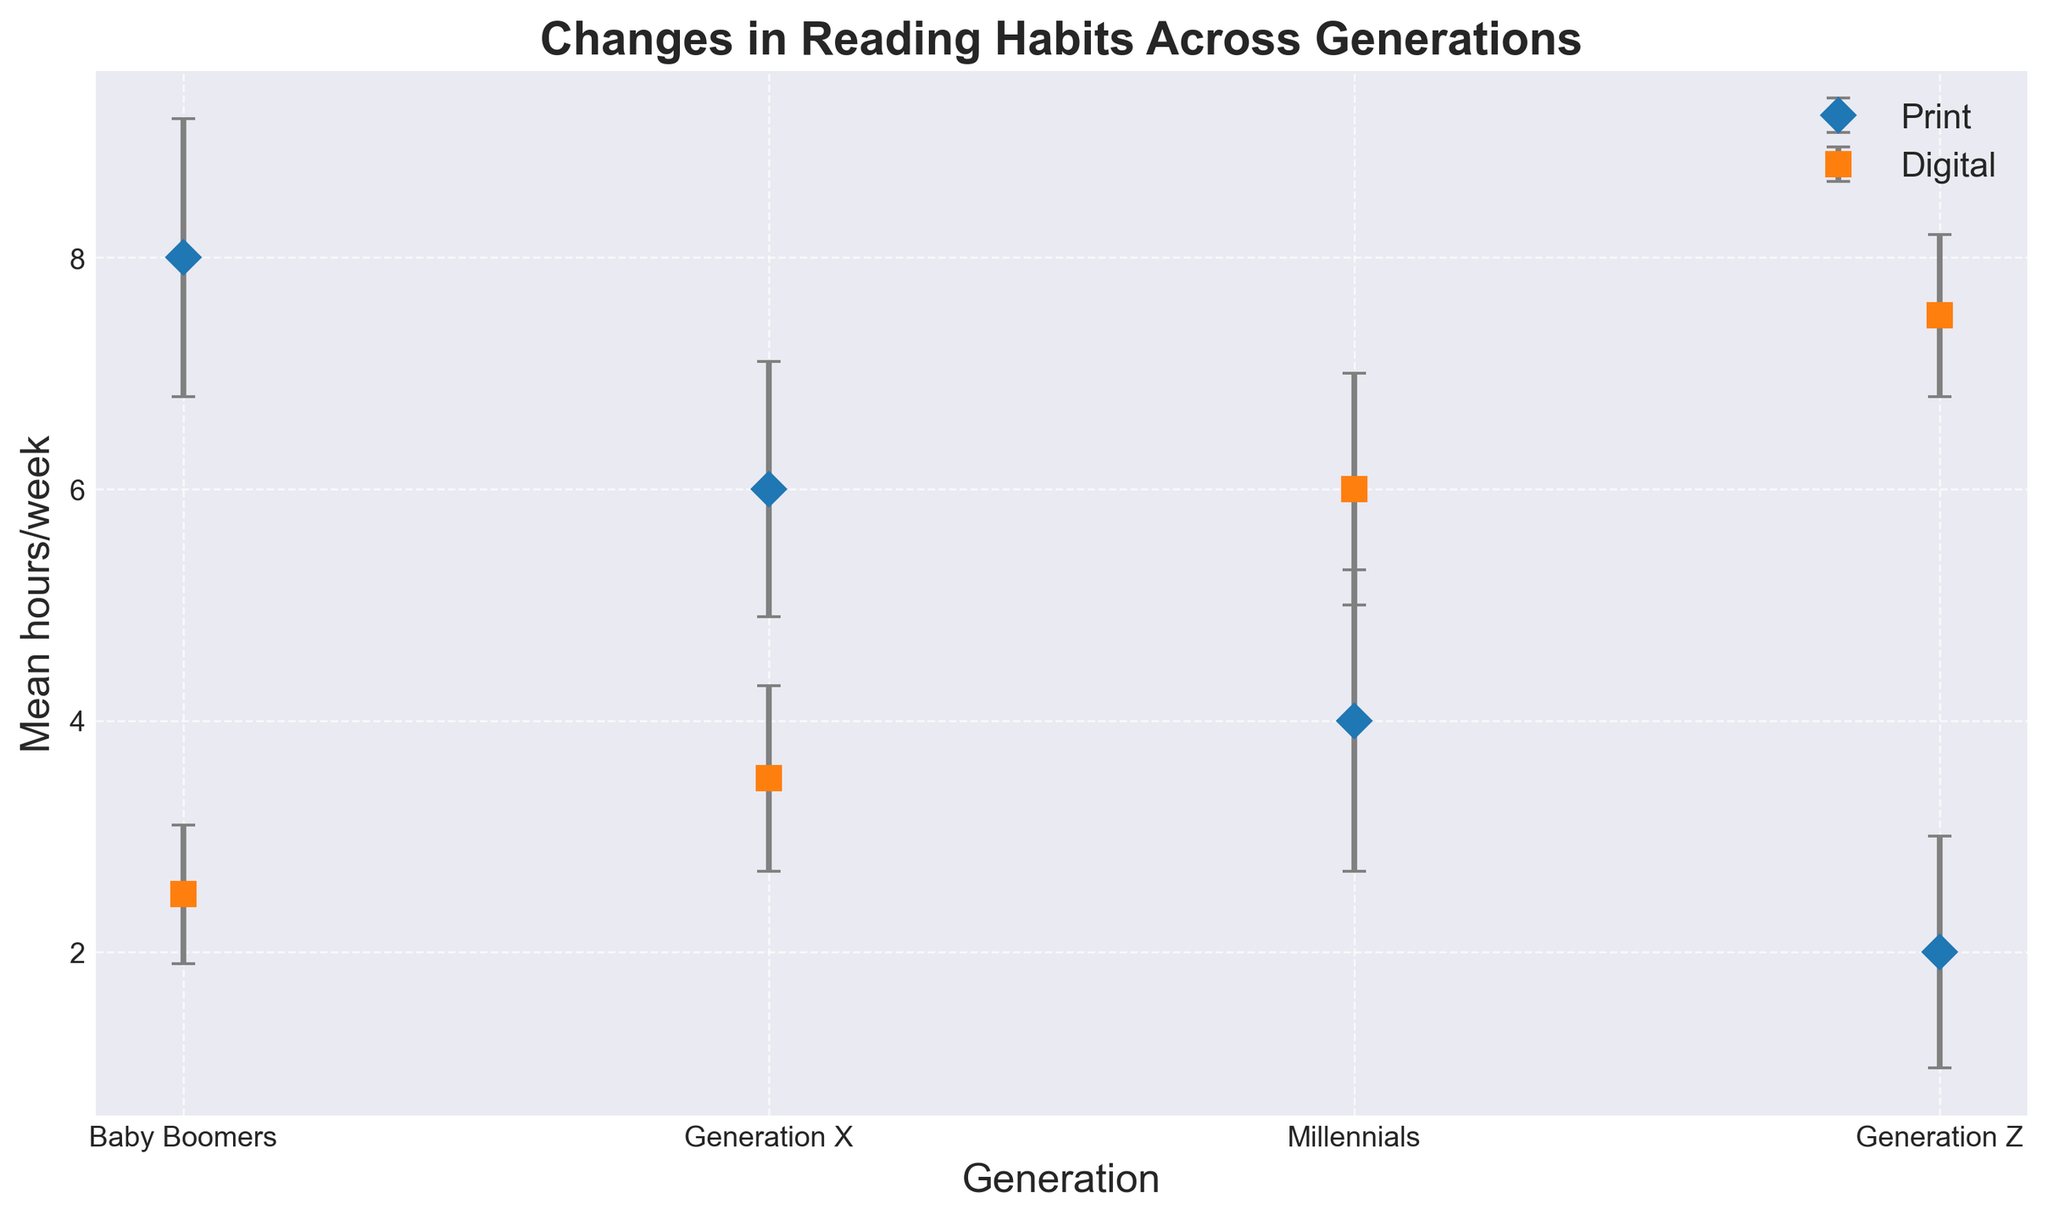What is the time difference in reading print vs. digital media for Baby Boomers? For Baby Boomers, the average time spent on print media is 8 hours/week and on digital media is 2.5 hours/week. The difference is calculated as 8 - 2.5.
Answer: 5.5 hours/week Which generation spends the most time on digital media? From the chart, it's evident that Generation Z spends the most time on digital media with an average of 7.5 hours/week.
Answer: Generation Z Compare the average time spent on print media by Generation X and Millennials. Which generation spends more time? Generation X spends 6 hours/week on print media, while Millennials spend 4 hours/week. Generation X spends more time.
Answer: Generation X What is the combined average reading time (print + digital) for Millennials? Millennials spend an average of 4 hours/week on print media and 6 hours/week on digital media. Their combined average reading time is 4 + 6.
Answer: 10 hours/week By how much does Generation Z’s digital reading time exceed its print reading time? Generation Z spends 7.5 hours/week on digital media and 2 hours/week on print media. The difference is 7.5 - 2.
Answer: 5.5 hours/week Which generation shows the smallest discrepancy between print and digital media consumption? Baby Boomers have 8 hours/week for print and 2.5 hours/week for digital, showing a 5.5-hour difference. Generation X has 6 hours/week for print and 3.5 hours/week for digital, showing a 2.5-hour difference. Millennials have 4 hours/week for print and 6 hours/week for digital, showing a 2-hour difference. Generation Z has 2 hours/week for print and 7.5 hours/week for digital, showing a 5.5-hour difference. Thus, Millennials show the smallest discrepancy of 2 hours.
Answer: Millennials What's the average time spent on print media across all generations? The average time spent on print media for Baby Boomers, Generation X, Millennials, and Generation Z is (8 + 6 + 4 + 2) / 4.
Answer: 5 hours/week How do Generation X’s average reading times for print and digital media compare visually in the chart? In the chart, the point for Generation X’s print media is higher up at 6 hours/week, while the point for digital media is lower at 3.5 hours/week, indicating they spend more time on print than digital.
Answer: Print > Digital What is the ratio of digital to print media consumption for Millennials? Millennials spend 6 hours/week on digital media and 4 hours/week on print media. The ratio is 6 / 4.
Answer: 1.5 Which generation has the highest error in their digital media reading time data? Looking at the chart, the generation with the largest error bar for digital media is Millennials, with an error of 1.0 hours/week.
Answer: Millennials 